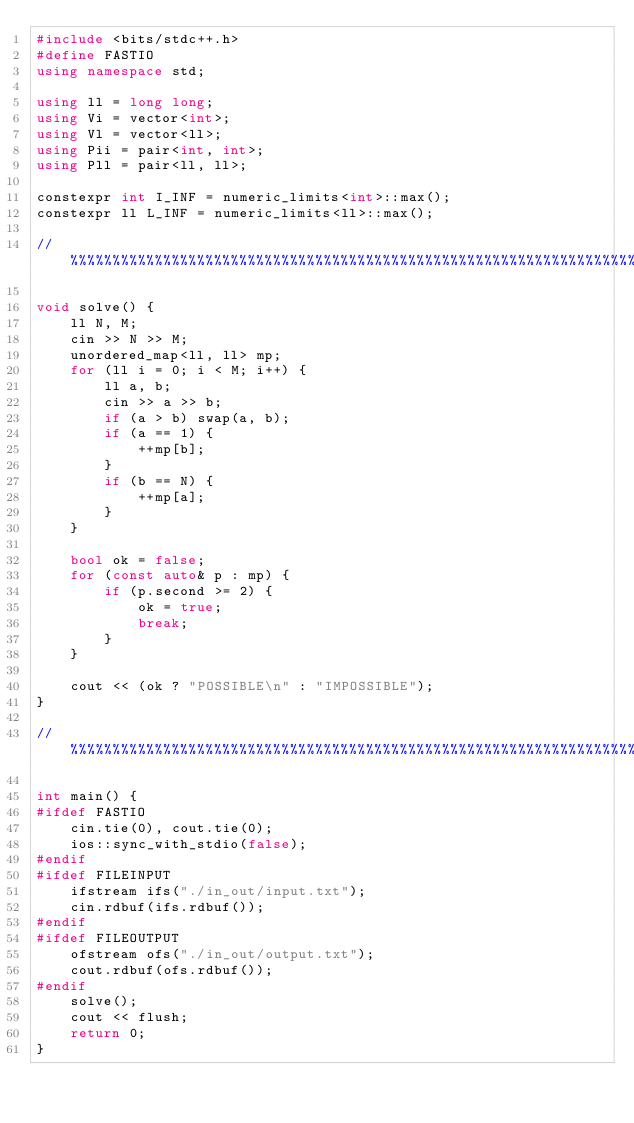<code> <loc_0><loc_0><loc_500><loc_500><_C++_>#include <bits/stdc++.h>
#define FASTIO
using namespace std;

using ll = long long;
using Vi = vector<int>;
using Vl = vector<ll>;
using Pii = pair<int, int>;
using Pll = pair<ll, ll>;

constexpr int I_INF = numeric_limits<int>::max();
constexpr ll L_INF = numeric_limits<ll>::max();

//%%%%%%%%%%%%%%%%%%%%%%%%%%%%%%%%%%%%%%%%%%%%%%%%%%%%%%%%%%%%%%%%%%%%%%%

void solve() {
    ll N, M;
    cin >> N >> M;
    unordered_map<ll, ll> mp;
    for (ll i = 0; i < M; i++) {
        ll a, b;
        cin >> a >> b;
        if (a > b) swap(a, b);
        if (a == 1) {
            ++mp[b];
        }
        if (b == N) {
            ++mp[a];
        }
    }

    bool ok = false;
    for (const auto& p : mp) {
        if (p.second >= 2) {
            ok = true;
            break;
        }
    }

    cout << (ok ? "POSSIBLE\n" : "IMPOSSIBLE");
}

//%%%%%%%%%%%%%%%%%%%%%%%%%%%%%%%%%%%%%%%%%%%%%%%%%%%%%%%%%%%%%%%%%%%%%%%

int main() {
#ifdef FASTIO
    cin.tie(0), cout.tie(0);
    ios::sync_with_stdio(false);
#endif
#ifdef FILEINPUT
    ifstream ifs("./in_out/input.txt");
    cin.rdbuf(ifs.rdbuf());
#endif
#ifdef FILEOUTPUT
    ofstream ofs("./in_out/output.txt");
    cout.rdbuf(ofs.rdbuf());
#endif
    solve();
    cout << flush;
    return 0;
}</code> 